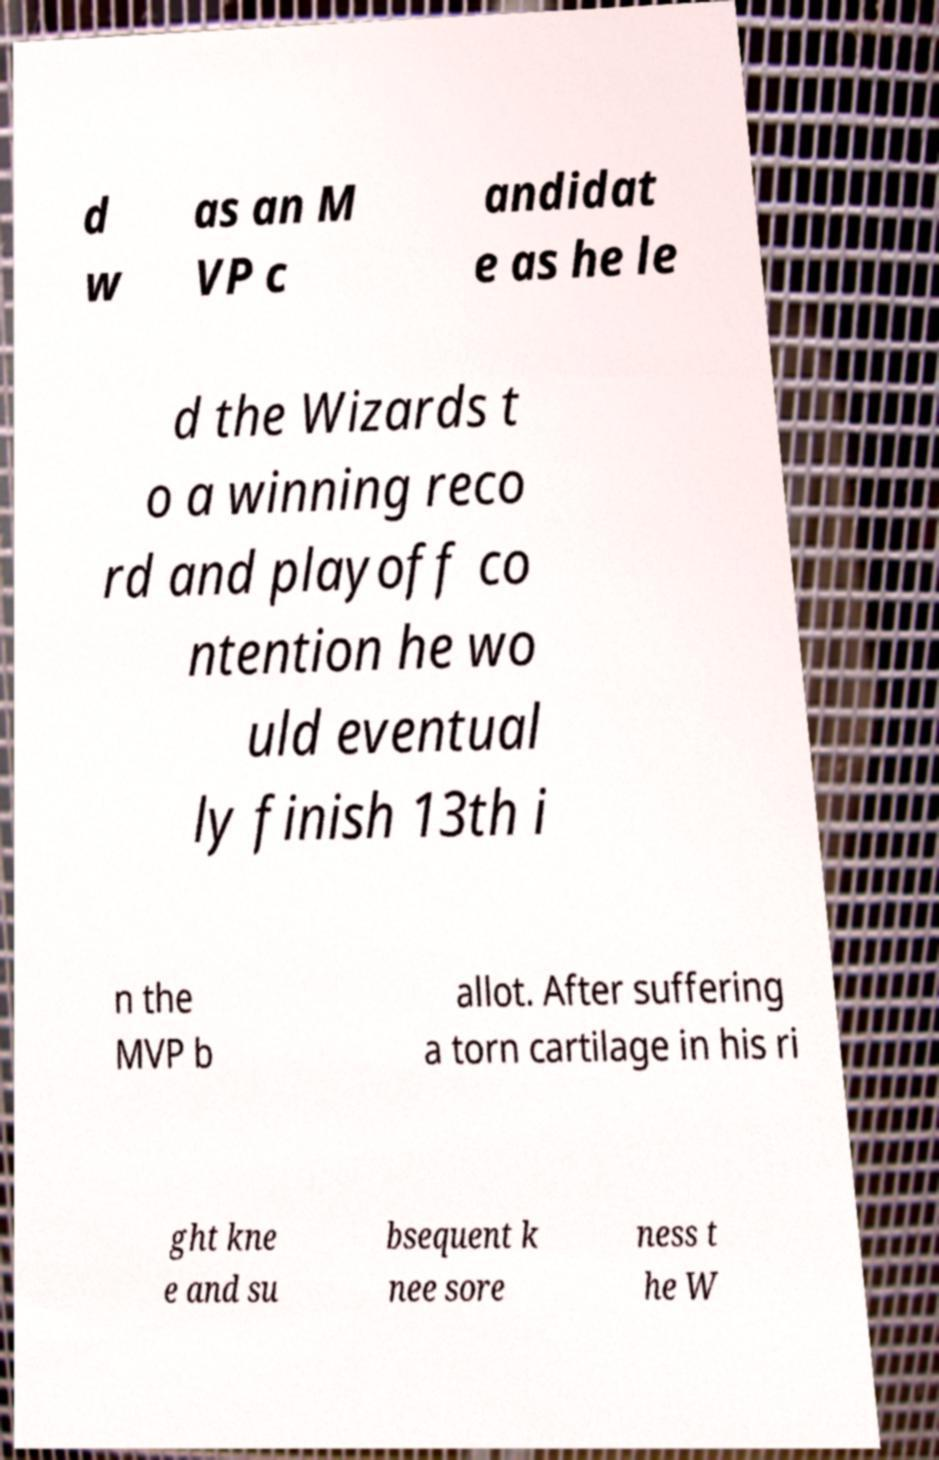Could you assist in decoding the text presented in this image and type it out clearly? d w as an M VP c andidat e as he le d the Wizards t o a winning reco rd and playoff co ntention he wo uld eventual ly finish 13th i n the MVP b allot. After suffering a torn cartilage in his ri ght kne e and su bsequent k nee sore ness t he W 